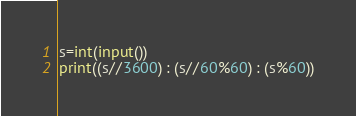Convert code to text. <code><loc_0><loc_0><loc_500><loc_500><_Python_>s=int(input())
print((s//3600) : (s//60%60) : (s%60))
</code> 